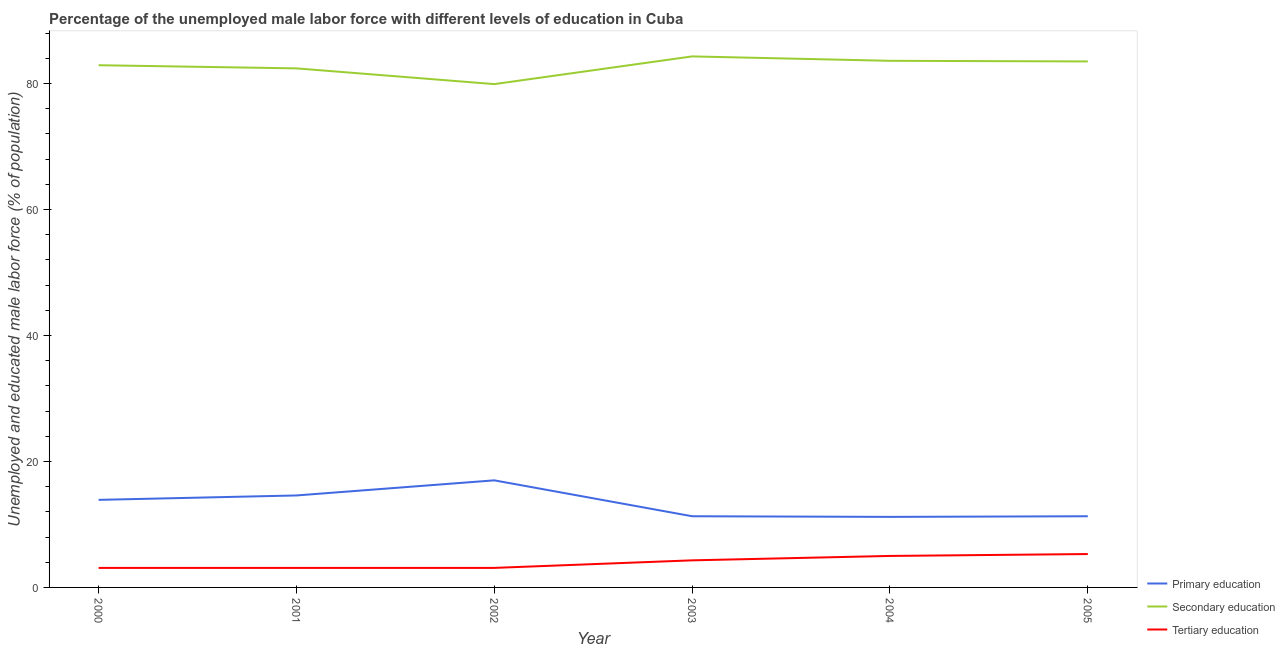How many different coloured lines are there?
Your answer should be compact. 3. Is the number of lines equal to the number of legend labels?
Give a very brief answer. Yes. What is the percentage of male labor force who received secondary education in 2003?
Make the answer very short. 84.3. Across all years, what is the maximum percentage of male labor force who received tertiary education?
Your answer should be compact. 5.3. Across all years, what is the minimum percentage of male labor force who received secondary education?
Your answer should be compact. 79.9. What is the total percentage of male labor force who received tertiary education in the graph?
Give a very brief answer. 23.9. What is the difference between the percentage of male labor force who received tertiary education in 2002 and that in 2003?
Your answer should be very brief. -1.2. What is the difference between the percentage of male labor force who received secondary education in 2001 and the percentage of male labor force who received primary education in 2000?
Provide a short and direct response. 68.5. What is the average percentage of male labor force who received secondary education per year?
Offer a very short reply. 82.77. In the year 2001, what is the difference between the percentage of male labor force who received tertiary education and percentage of male labor force who received primary education?
Your answer should be compact. -11.5. What is the ratio of the percentage of male labor force who received secondary education in 2001 to that in 2002?
Ensure brevity in your answer.  1.03. Is the percentage of male labor force who received primary education in 2003 less than that in 2004?
Your answer should be compact. No. What is the difference between the highest and the second highest percentage of male labor force who received primary education?
Ensure brevity in your answer.  2.4. What is the difference between the highest and the lowest percentage of male labor force who received secondary education?
Your answer should be compact. 4.4. Is the sum of the percentage of male labor force who received primary education in 2000 and 2002 greater than the maximum percentage of male labor force who received tertiary education across all years?
Ensure brevity in your answer.  Yes. Is it the case that in every year, the sum of the percentage of male labor force who received primary education and percentage of male labor force who received secondary education is greater than the percentage of male labor force who received tertiary education?
Offer a terse response. Yes. Does the percentage of male labor force who received secondary education monotonically increase over the years?
Keep it short and to the point. No. Is the percentage of male labor force who received tertiary education strictly less than the percentage of male labor force who received primary education over the years?
Make the answer very short. Yes. How many lines are there?
Offer a terse response. 3. Are the values on the major ticks of Y-axis written in scientific E-notation?
Give a very brief answer. No. Does the graph contain any zero values?
Offer a very short reply. No. Does the graph contain grids?
Make the answer very short. No. How are the legend labels stacked?
Offer a terse response. Vertical. What is the title of the graph?
Make the answer very short. Percentage of the unemployed male labor force with different levels of education in Cuba. What is the label or title of the Y-axis?
Provide a succinct answer. Unemployed and educated male labor force (% of population). What is the Unemployed and educated male labor force (% of population) of Primary education in 2000?
Give a very brief answer. 13.9. What is the Unemployed and educated male labor force (% of population) of Secondary education in 2000?
Ensure brevity in your answer.  82.9. What is the Unemployed and educated male labor force (% of population) of Tertiary education in 2000?
Your answer should be very brief. 3.1. What is the Unemployed and educated male labor force (% of population) of Primary education in 2001?
Offer a very short reply. 14.6. What is the Unemployed and educated male labor force (% of population) of Secondary education in 2001?
Make the answer very short. 82.4. What is the Unemployed and educated male labor force (% of population) of Tertiary education in 2001?
Your response must be concise. 3.1. What is the Unemployed and educated male labor force (% of population) of Secondary education in 2002?
Your answer should be compact. 79.9. What is the Unemployed and educated male labor force (% of population) in Tertiary education in 2002?
Make the answer very short. 3.1. What is the Unemployed and educated male labor force (% of population) in Primary education in 2003?
Your response must be concise. 11.3. What is the Unemployed and educated male labor force (% of population) in Secondary education in 2003?
Provide a succinct answer. 84.3. What is the Unemployed and educated male labor force (% of population) of Tertiary education in 2003?
Make the answer very short. 4.3. What is the Unemployed and educated male labor force (% of population) of Primary education in 2004?
Provide a short and direct response. 11.2. What is the Unemployed and educated male labor force (% of population) in Secondary education in 2004?
Provide a succinct answer. 83.6. What is the Unemployed and educated male labor force (% of population) of Tertiary education in 2004?
Your answer should be compact. 5. What is the Unemployed and educated male labor force (% of population) of Primary education in 2005?
Make the answer very short. 11.3. What is the Unemployed and educated male labor force (% of population) in Secondary education in 2005?
Your response must be concise. 83.5. What is the Unemployed and educated male labor force (% of population) in Tertiary education in 2005?
Ensure brevity in your answer.  5.3. Across all years, what is the maximum Unemployed and educated male labor force (% of population) in Primary education?
Offer a terse response. 17. Across all years, what is the maximum Unemployed and educated male labor force (% of population) of Secondary education?
Your answer should be very brief. 84.3. Across all years, what is the maximum Unemployed and educated male labor force (% of population) of Tertiary education?
Keep it short and to the point. 5.3. Across all years, what is the minimum Unemployed and educated male labor force (% of population) in Primary education?
Keep it short and to the point. 11.2. Across all years, what is the minimum Unemployed and educated male labor force (% of population) of Secondary education?
Give a very brief answer. 79.9. Across all years, what is the minimum Unemployed and educated male labor force (% of population) in Tertiary education?
Your answer should be very brief. 3.1. What is the total Unemployed and educated male labor force (% of population) of Primary education in the graph?
Provide a short and direct response. 79.3. What is the total Unemployed and educated male labor force (% of population) in Secondary education in the graph?
Give a very brief answer. 496.6. What is the total Unemployed and educated male labor force (% of population) of Tertiary education in the graph?
Your response must be concise. 23.9. What is the difference between the Unemployed and educated male labor force (% of population) in Primary education in 2000 and that in 2001?
Provide a short and direct response. -0.7. What is the difference between the Unemployed and educated male labor force (% of population) of Secondary education in 2000 and that in 2001?
Give a very brief answer. 0.5. What is the difference between the Unemployed and educated male labor force (% of population) in Tertiary education in 2000 and that in 2002?
Provide a succinct answer. 0. What is the difference between the Unemployed and educated male labor force (% of population) in Primary education in 2000 and that in 2003?
Make the answer very short. 2.6. What is the difference between the Unemployed and educated male labor force (% of population) in Tertiary education in 2000 and that in 2003?
Ensure brevity in your answer.  -1.2. What is the difference between the Unemployed and educated male labor force (% of population) of Primary education in 2000 and that in 2004?
Your answer should be very brief. 2.7. What is the difference between the Unemployed and educated male labor force (% of population) in Secondary education in 2000 and that in 2004?
Give a very brief answer. -0.7. What is the difference between the Unemployed and educated male labor force (% of population) in Tertiary education in 2000 and that in 2004?
Offer a very short reply. -1.9. What is the difference between the Unemployed and educated male labor force (% of population) in Primary education in 2000 and that in 2005?
Give a very brief answer. 2.6. What is the difference between the Unemployed and educated male labor force (% of population) in Tertiary education in 2000 and that in 2005?
Provide a short and direct response. -2.2. What is the difference between the Unemployed and educated male labor force (% of population) of Primary education in 2001 and that in 2002?
Keep it short and to the point. -2.4. What is the difference between the Unemployed and educated male labor force (% of population) in Secondary education in 2001 and that in 2002?
Give a very brief answer. 2.5. What is the difference between the Unemployed and educated male labor force (% of population) of Primary education in 2001 and that in 2003?
Keep it short and to the point. 3.3. What is the difference between the Unemployed and educated male labor force (% of population) in Tertiary education in 2001 and that in 2004?
Offer a very short reply. -1.9. What is the difference between the Unemployed and educated male labor force (% of population) of Tertiary education in 2001 and that in 2005?
Your answer should be very brief. -2.2. What is the difference between the Unemployed and educated male labor force (% of population) in Primary education in 2002 and that in 2003?
Keep it short and to the point. 5.7. What is the difference between the Unemployed and educated male labor force (% of population) of Secondary education in 2002 and that in 2003?
Provide a succinct answer. -4.4. What is the difference between the Unemployed and educated male labor force (% of population) in Primary education in 2002 and that in 2004?
Offer a very short reply. 5.8. What is the difference between the Unemployed and educated male labor force (% of population) of Primary education in 2002 and that in 2005?
Your response must be concise. 5.7. What is the difference between the Unemployed and educated male labor force (% of population) in Primary education in 2003 and that in 2004?
Ensure brevity in your answer.  0.1. What is the difference between the Unemployed and educated male labor force (% of population) of Secondary education in 2003 and that in 2004?
Your answer should be compact. 0.7. What is the difference between the Unemployed and educated male labor force (% of population) of Tertiary education in 2003 and that in 2005?
Keep it short and to the point. -1. What is the difference between the Unemployed and educated male labor force (% of population) of Primary education in 2004 and that in 2005?
Your answer should be very brief. -0.1. What is the difference between the Unemployed and educated male labor force (% of population) of Tertiary education in 2004 and that in 2005?
Provide a short and direct response. -0.3. What is the difference between the Unemployed and educated male labor force (% of population) in Primary education in 2000 and the Unemployed and educated male labor force (% of population) in Secondary education in 2001?
Make the answer very short. -68.5. What is the difference between the Unemployed and educated male labor force (% of population) of Secondary education in 2000 and the Unemployed and educated male labor force (% of population) of Tertiary education in 2001?
Keep it short and to the point. 79.8. What is the difference between the Unemployed and educated male labor force (% of population) of Primary education in 2000 and the Unemployed and educated male labor force (% of population) of Secondary education in 2002?
Make the answer very short. -66. What is the difference between the Unemployed and educated male labor force (% of population) in Secondary education in 2000 and the Unemployed and educated male labor force (% of population) in Tertiary education in 2002?
Offer a very short reply. 79.8. What is the difference between the Unemployed and educated male labor force (% of population) of Primary education in 2000 and the Unemployed and educated male labor force (% of population) of Secondary education in 2003?
Your answer should be very brief. -70.4. What is the difference between the Unemployed and educated male labor force (% of population) of Secondary education in 2000 and the Unemployed and educated male labor force (% of population) of Tertiary education in 2003?
Make the answer very short. 78.6. What is the difference between the Unemployed and educated male labor force (% of population) in Primary education in 2000 and the Unemployed and educated male labor force (% of population) in Secondary education in 2004?
Make the answer very short. -69.7. What is the difference between the Unemployed and educated male labor force (% of population) of Secondary education in 2000 and the Unemployed and educated male labor force (% of population) of Tertiary education in 2004?
Provide a succinct answer. 77.9. What is the difference between the Unemployed and educated male labor force (% of population) of Primary education in 2000 and the Unemployed and educated male labor force (% of population) of Secondary education in 2005?
Ensure brevity in your answer.  -69.6. What is the difference between the Unemployed and educated male labor force (% of population) in Primary education in 2000 and the Unemployed and educated male labor force (% of population) in Tertiary education in 2005?
Provide a short and direct response. 8.6. What is the difference between the Unemployed and educated male labor force (% of population) of Secondary education in 2000 and the Unemployed and educated male labor force (% of population) of Tertiary education in 2005?
Your response must be concise. 77.6. What is the difference between the Unemployed and educated male labor force (% of population) of Primary education in 2001 and the Unemployed and educated male labor force (% of population) of Secondary education in 2002?
Your response must be concise. -65.3. What is the difference between the Unemployed and educated male labor force (% of population) of Primary education in 2001 and the Unemployed and educated male labor force (% of population) of Tertiary education in 2002?
Ensure brevity in your answer.  11.5. What is the difference between the Unemployed and educated male labor force (% of population) of Secondary education in 2001 and the Unemployed and educated male labor force (% of population) of Tertiary education in 2002?
Keep it short and to the point. 79.3. What is the difference between the Unemployed and educated male labor force (% of population) in Primary education in 2001 and the Unemployed and educated male labor force (% of population) in Secondary education in 2003?
Offer a very short reply. -69.7. What is the difference between the Unemployed and educated male labor force (% of population) of Secondary education in 2001 and the Unemployed and educated male labor force (% of population) of Tertiary education in 2003?
Provide a succinct answer. 78.1. What is the difference between the Unemployed and educated male labor force (% of population) in Primary education in 2001 and the Unemployed and educated male labor force (% of population) in Secondary education in 2004?
Your answer should be compact. -69. What is the difference between the Unemployed and educated male labor force (% of population) of Primary education in 2001 and the Unemployed and educated male labor force (% of population) of Tertiary education in 2004?
Give a very brief answer. 9.6. What is the difference between the Unemployed and educated male labor force (% of population) in Secondary education in 2001 and the Unemployed and educated male labor force (% of population) in Tertiary education in 2004?
Give a very brief answer. 77.4. What is the difference between the Unemployed and educated male labor force (% of population) in Primary education in 2001 and the Unemployed and educated male labor force (% of population) in Secondary education in 2005?
Your answer should be very brief. -68.9. What is the difference between the Unemployed and educated male labor force (% of population) in Secondary education in 2001 and the Unemployed and educated male labor force (% of population) in Tertiary education in 2005?
Your answer should be very brief. 77.1. What is the difference between the Unemployed and educated male labor force (% of population) of Primary education in 2002 and the Unemployed and educated male labor force (% of population) of Secondary education in 2003?
Offer a very short reply. -67.3. What is the difference between the Unemployed and educated male labor force (% of population) in Secondary education in 2002 and the Unemployed and educated male labor force (% of population) in Tertiary education in 2003?
Provide a succinct answer. 75.6. What is the difference between the Unemployed and educated male labor force (% of population) in Primary education in 2002 and the Unemployed and educated male labor force (% of population) in Secondary education in 2004?
Give a very brief answer. -66.6. What is the difference between the Unemployed and educated male labor force (% of population) of Primary education in 2002 and the Unemployed and educated male labor force (% of population) of Tertiary education in 2004?
Provide a succinct answer. 12. What is the difference between the Unemployed and educated male labor force (% of population) of Secondary education in 2002 and the Unemployed and educated male labor force (% of population) of Tertiary education in 2004?
Your response must be concise. 74.9. What is the difference between the Unemployed and educated male labor force (% of population) of Primary education in 2002 and the Unemployed and educated male labor force (% of population) of Secondary education in 2005?
Give a very brief answer. -66.5. What is the difference between the Unemployed and educated male labor force (% of population) of Secondary education in 2002 and the Unemployed and educated male labor force (% of population) of Tertiary education in 2005?
Give a very brief answer. 74.6. What is the difference between the Unemployed and educated male labor force (% of population) in Primary education in 2003 and the Unemployed and educated male labor force (% of population) in Secondary education in 2004?
Your answer should be compact. -72.3. What is the difference between the Unemployed and educated male labor force (% of population) in Primary education in 2003 and the Unemployed and educated male labor force (% of population) in Tertiary education in 2004?
Provide a short and direct response. 6.3. What is the difference between the Unemployed and educated male labor force (% of population) in Secondary education in 2003 and the Unemployed and educated male labor force (% of population) in Tertiary education in 2004?
Your response must be concise. 79.3. What is the difference between the Unemployed and educated male labor force (% of population) in Primary education in 2003 and the Unemployed and educated male labor force (% of population) in Secondary education in 2005?
Provide a succinct answer. -72.2. What is the difference between the Unemployed and educated male labor force (% of population) in Secondary education in 2003 and the Unemployed and educated male labor force (% of population) in Tertiary education in 2005?
Your answer should be compact. 79. What is the difference between the Unemployed and educated male labor force (% of population) in Primary education in 2004 and the Unemployed and educated male labor force (% of population) in Secondary education in 2005?
Offer a very short reply. -72.3. What is the difference between the Unemployed and educated male labor force (% of population) in Primary education in 2004 and the Unemployed and educated male labor force (% of population) in Tertiary education in 2005?
Ensure brevity in your answer.  5.9. What is the difference between the Unemployed and educated male labor force (% of population) of Secondary education in 2004 and the Unemployed and educated male labor force (% of population) of Tertiary education in 2005?
Your answer should be very brief. 78.3. What is the average Unemployed and educated male labor force (% of population) in Primary education per year?
Give a very brief answer. 13.22. What is the average Unemployed and educated male labor force (% of population) of Secondary education per year?
Offer a very short reply. 82.77. What is the average Unemployed and educated male labor force (% of population) in Tertiary education per year?
Provide a succinct answer. 3.98. In the year 2000, what is the difference between the Unemployed and educated male labor force (% of population) in Primary education and Unemployed and educated male labor force (% of population) in Secondary education?
Your response must be concise. -69. In the year 2000, what is the difference between the Unemployed and educated male labor force (% of population) in Primary education and Unemployed and educated male labor force (% of population) in Tertiary education?
Your answer should be compact. 10.8. In the year 2000, what is the difference between the Unemployed and educated male labor force (% of population) of Secondary education and Unemployed and educated male labor force (% of population) of Tertiary education?
Provide a succinct answer. 79.8. In the year 2001, what is the difference between the Unemployed and educated male labor force (% of population) in Primary education and Unemployed and educated male labor force (% of population) in Secondary education?
Your response must be concise. -67.8. In the year 2001, what is the difference between the Unemployed and educated male labor force (% of population) in Primary education and Unemployed and educated male labor force (% of population) in Tertiary education?
Offer a terse response. 11.5. In the year 2001, what is the difference between the Unemployed and educated male labor force (% of population) of Secondary education and Unemployed and educated male labor force (% of population) of Tertiary education?
Keep it short and to the point. 79.3. In the year 2002, what is the difference between the Unemployed and educated male labor force (% of population) in Primary education and Unemployed and educated male labor force (% of population) in Secondary education?
Offer a terse response. -62.9. In the year 2002, what is the difference between the Unemployed and educated male labor force (% of population) of Primary education and Unemployed and educated male labor force (% of population) of Tertiary education?
Offer a very short reply. 13.9. In the year 2002, what is the difference between the Unemployed and educated male labor force (% of population) in Secondary education and Unemployed and educated male labor force (% of population) in Tertiary education?
Ensure brevity in your answer.  76.8. In the year 2003, what is the difference between the Unemployed and educated male labor force (% of population) in Primary education and Unemployed and educated male labor force (% of population) in Secondary education?
Keep it short and to the point. -73. In the year 2003, what is the difference between the Unemployed and educated male labor force (% of population) in Primary education and Unemployed and educated male labor force (% of population) in Tertiary education?
Provide a succinct answer. 7. In the year 2003, what is the difference between the Unemployed and educated male labor force (% of population) in Secondary education and Unemployed and educated male labor force (% of population) in Tertiary education?
Keep it short and to the point. 80. In the year 2004, what is the difference between the Unemployed and educated male labor force (% of population) in Primary education and Unemployed and educated male labor force (% of population) in Secondary education?
Your answer should be very brief. -72.4. In the year 2004, what is the difference between the Unemployed and educated male labor force (% of population) of Primary education and Unemployed and educated male labor force (% of population) of Tertiary education?
Your answer should be compact. 6.2. In the year 2004, what is the difference between the Unemployed and educated male labor force (% of population) of Secondary education and Unemployed and educated male labor force (% of population) of Tertiary education?
Offer a very short reply. 78.6. In the year 2005, what is the difference between the Unemployed and educated male labor force (% of population) of Primary education and Unemployed and educated male labor force (% of population) of Secondary education?
Provide a succinct answer. -72.2. In the year 2005, what is the difference between the Unemployed and educated male labor force (% of population) of Primary education and Unemployed and educated male labor force (% of population) of Tertiary education?
Your answer should be very brief. 6. In the year 2005, what is the difference between the Unemployed and educated male labor force (% of population) in Secondary education and Unemployed and educated male labor force (% of population) in Tertiary education?
Keep it short and to the point. 78.2. What is the ratio of the Unemployed and educated male labor force (% of population) of Primary education in 2000 to that in 2001?
Provide a succinct answer. 0.95. What is the ratio of the Unemployed and educated male labor force (% of population) in Primary education in 2000 to that in 2002?
Provide a succinct answer. 0.82. What is the ratio of the Unemployed and educated male labor force (% of population) of Secondary education in 2000 to that in 2002?
Your response must be concise. 1.04. What is the ratio of the Unemployed and educated male labor force (% of population) in Tertiary education in 2000 to that in 2002?
Provide a short and direct response. 1. What is the ratio of the Unemployed and educated male labor force (% of population) in Primary education in 2000 to that in 2003?
Provide a succinct answer. 1.23. What is the ratio of the Unemployed and educated male labor force (% of population) in Secondary education in 2000 to that in 2003?
Ensure brevity in your answer.  0.98. What is the ratio of the Unemployed and educated male labor force (% of population) of Tertiary education in 2000 to that in 2003?
Your answer should be compact. 0.72. What is the ratio of the Unemployed and educated male labor force (% of population) of Primary education in 2000 to that in 2004?
Ensure brevity in your answer.  1.24. What is the ratio of the Unemployed and educated male labor force (% of population) in Tertiary education in 2000 to that in 2004?
Offer a very short reply. 0.62. What is the ratio of the Unemployed and educated male labor force (% of population) in Primary education in 2000 to that in 2005?
Make the answer very short. 1.23. What is the ratio of the Unemployed and educated male labor force (% of population) in Secondary education in 2000 to that in 2005?
Your answer should be compact. 0.99. What is the ratio of the Unemployed and educated male labor force (% of population) in Tertiary education in 2000 to that in 2005?
Offer a very short reply. 0.58. What is the ratio of the Unemployed and educated male labor force (% of population) in Primary education in 2001 to that in 2002?
Offer a terse response. 0.86. What is the ratio of the Unemployed and educated male labor force (% of population) in Secondary education in 2001 to that in 2002?
Offer a terse response. 1.03. What is the ratio of the Unemployed and educated male labor force (% of population) of Tertiary education in 2001 to that in 2002?
Your answer should be compact. 1. What is the ratio of the Unemployed and educated male labor force (% of population) in Primary education in 2001 to that in 2003?
Make the answer very short. 1.29. What is the ratio of the Unemployed and educated male labor force (% of population) of Secondary education in 2001 to that in 2003?
Make the answer very short. 0.98. What is the ratio of the Unemployed and educated male labor force (% of population) in Tertiary education in 2001 to that in 2003?
Your response must be concise. 0.72. What is the ratio of the Unemployed and educated male labor force (% of population) of Primary education in 2001 to that in 2004?
Ensure brevity in your answer.  1.3. What is the ratio of the Unemployed and educated male labor force (% of population) of Secondary education in 2001 to that in 2004?
Offer a terse response. 0.99. What is the ratio of the Unemployed and educated male labor force (% of population) of Tertiary education in 2001 to that in 2004?
Ensure brevity in your answer.  0.62. What is the ratio of the Unemployed and educated male labor force (% of population) in Primary education in 2001 to that in 2005?
Offer a terse response. 1.29. What is the ratio of the Unemployed and educated male labor force (% of population) in Tertiary education in 2001 to that in 2005?
Your answer should be very brief. 0.58. What is the ratio of the Unemployed and educated male labor force (% of population) of Primary education in 2002 to that in 2003?
Your response must be concise. 1.5. What is the ratio of the Unemployed and educated male labor force (% of population) of Secondary education in 2002 to that in 2003?
Provide a succinct answer. 0.95. What is the ratio of the Unemployed and educated male labor force (% of population) of Tertiary education in 2002 to that in 2003?
Ensure brevity in your answer.  0.72. What is the ratio of the Unemployed and educated male labor force (% of population) of Primary education in 2002 to that in 2004?
Your answer should be very brief. 1.52. What is the ratio of the Unemployed and educated male labor force (% of population) of Secondary education in 2002 to that in 2004?
Make the answer very short. 0.96. What is the ratio of the Unemployed and educated male labor force (% of population) in Tertiary education in 2002 to that in 2004?
Make the answer very short. 0.62. What is the ratio of the Unemployed and educated male labor force (% of population) of Primary education in 2002 to that in 2005?
Your response must be concise. 1.5. What is the ratio of the Unemployed and educated male labor force (% of population) in Secondary education in 2002 to that in 2005?
Give a very brief answer. 0.96. What is the ratio of the Unemployed and educated male labor force (% of population) in Tertiary education in 2002 to that in 2005?
Ensure brevity in your answer.  0.58. What is the ratio of the Unemployed and educated male labor force (% of population) of Primary education in 2003 to that in 2004?
Offer a very short reply. 1.01. What is the ratio of the Unemployed and educated male labor force (% of population) of Secondary education in 2003 to that in 2004?
Keep it short and to the point. 1.01. What is the ratio of the Unemployed and educated male labor force (% of population) of Tertiary education in 2003 to that in 2004?
Keep it short and to the point. 0.86. What is the ratio of the Unemployed and educated male labor force (% of population) of Secondary education in 2003 to that in 2005?
Provide a short and direct response. 1.01. What is the ratio of the Unemployed and educated male labor force (% of population) in Tertiary education in 2003 to that in 2005?
Your answer should be very brief. 0.81. What is the ratio of the Unemployed and educated male labor force (% of population) of Primary education in 2004 to that in 2005?
Your answer should be compact. 0.99. What is the ratio of the Unemployed and educated male labor force (% of population) of Tertiary education in 2004 to that in 2005?
Provide a short and direct response. 0.94. What is the difference between the highest and the second highest Unemployed and educated male labor force (% of population) of Primary education?
Your response must be concise. 2.4. What is the difference between the highest and the second highest Unemployed and educated male labor force (% of population) of Secondary education?
Make the answer very short. 0.7. What is the difference between the highest and the second highest Unemployed and educated male labor force (% of population) of Tertiary education?
Keep it short and to the point. 0.3. What is the difference between the highest and the lowest Unemployed and educated male labor force (% of population) of Secondary education?
Keep it short and to the point. 4.4. What is the difference between the highest and the lowest Unemployed and educated male labor force (% of population) of Tertiary education?
Make the answer very short. 2.2. 